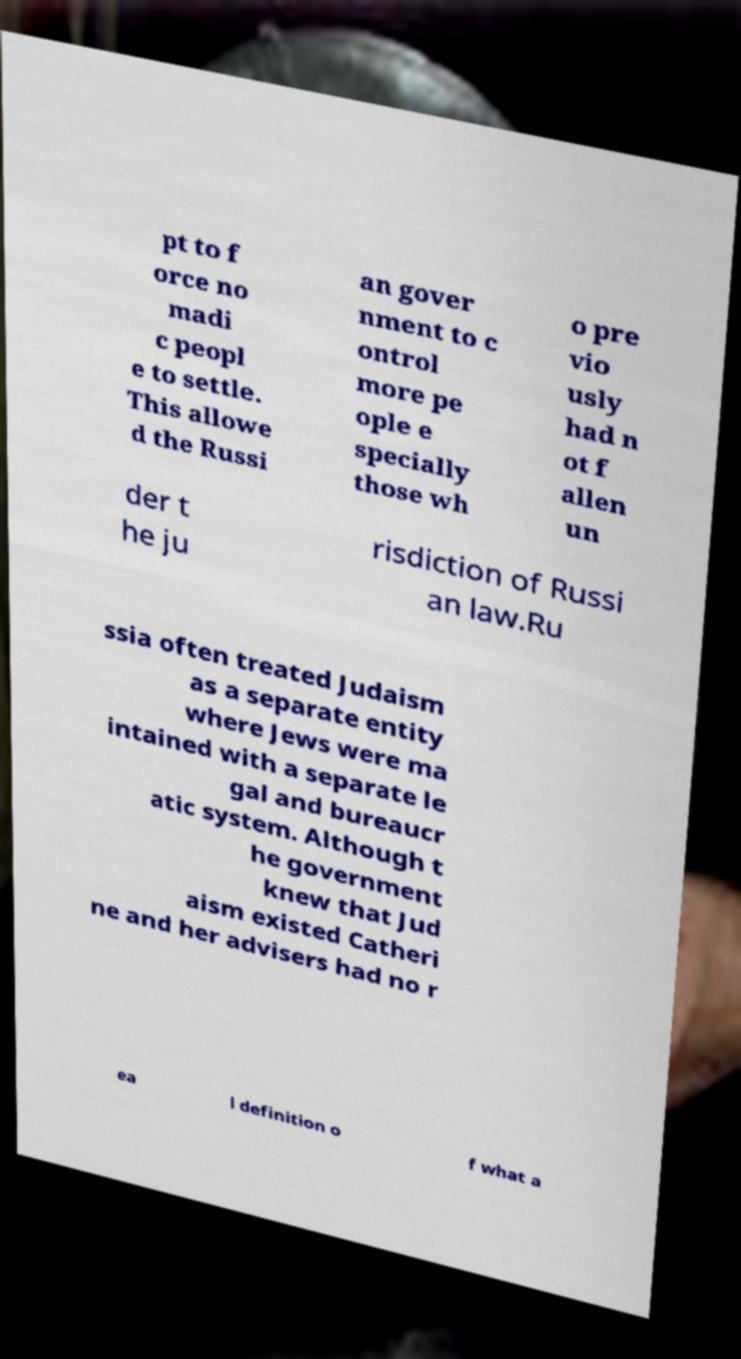Could you assist in decoding the text presented in this image and type it out clearly? pt to f orce no madi c peopl e to settle. This allowe d the Russi an gover nment to c ontrol more pe ople e specially those wh o pre vio usly had n ot f allen un der t he ju risdiction of Russi an law.Ru ssia often treated Judaism as a separate entity where Jews were ma intained with a separate le gal and bureaucr atic system. Although t he government knew that Jud aism existed Catheri ne and her advisers had no r ea l definition o f what a 